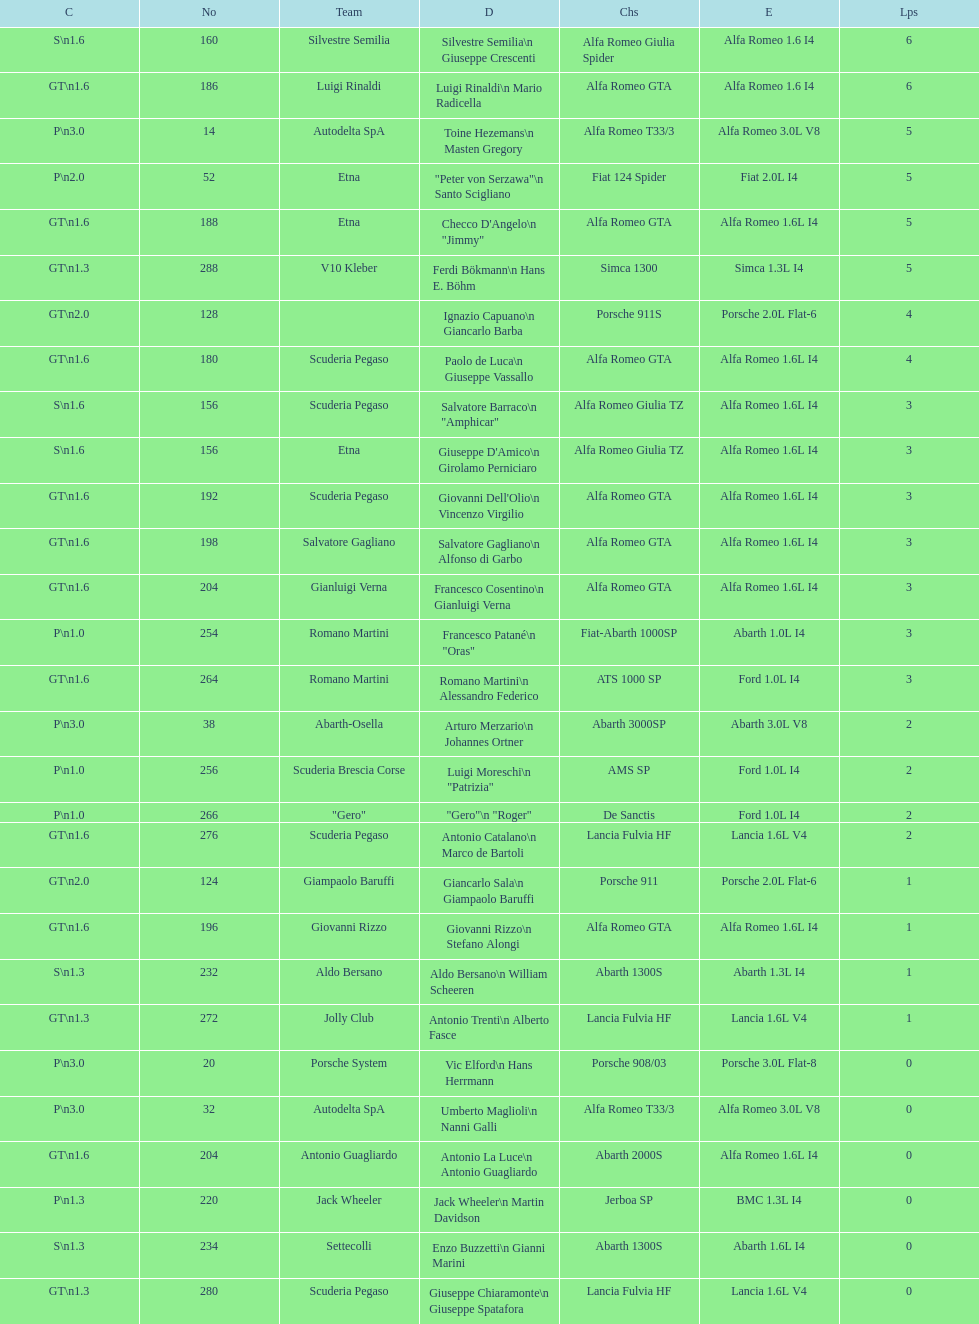Name the only american who did not finish the race. Masten Gregory. 